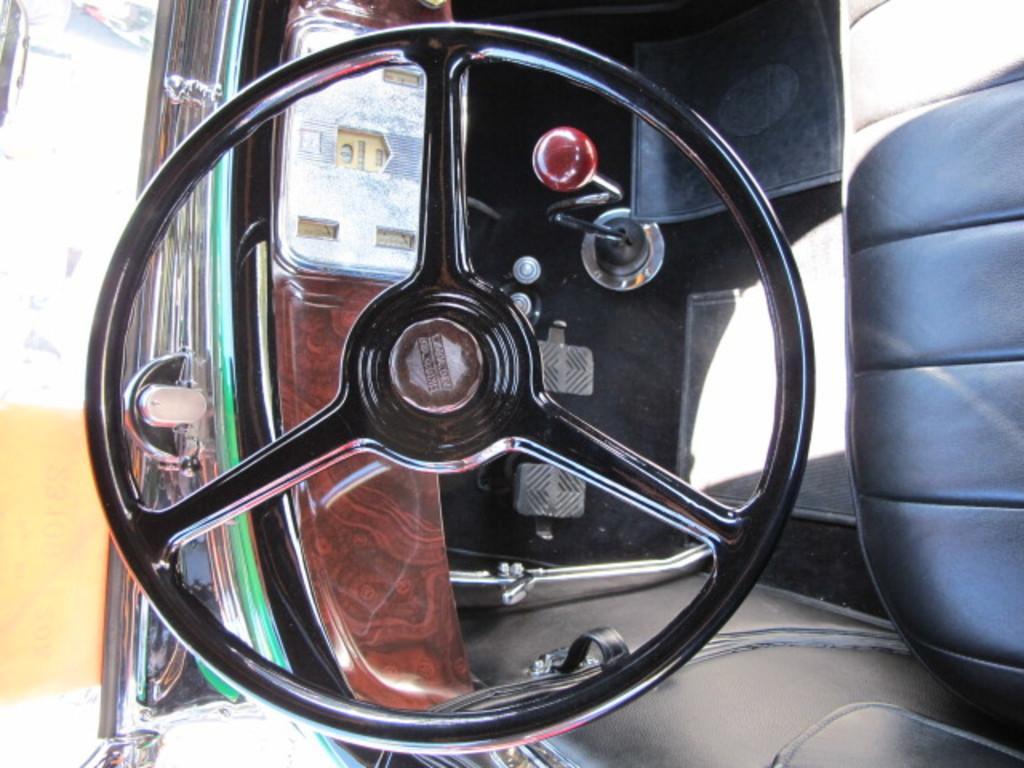Please provide a concise description of this image. This image is taken in a car. In the middle of the image there is a steering and dashboard. On the right side of the image there is a seat. At the bottom of the image there is a door. 